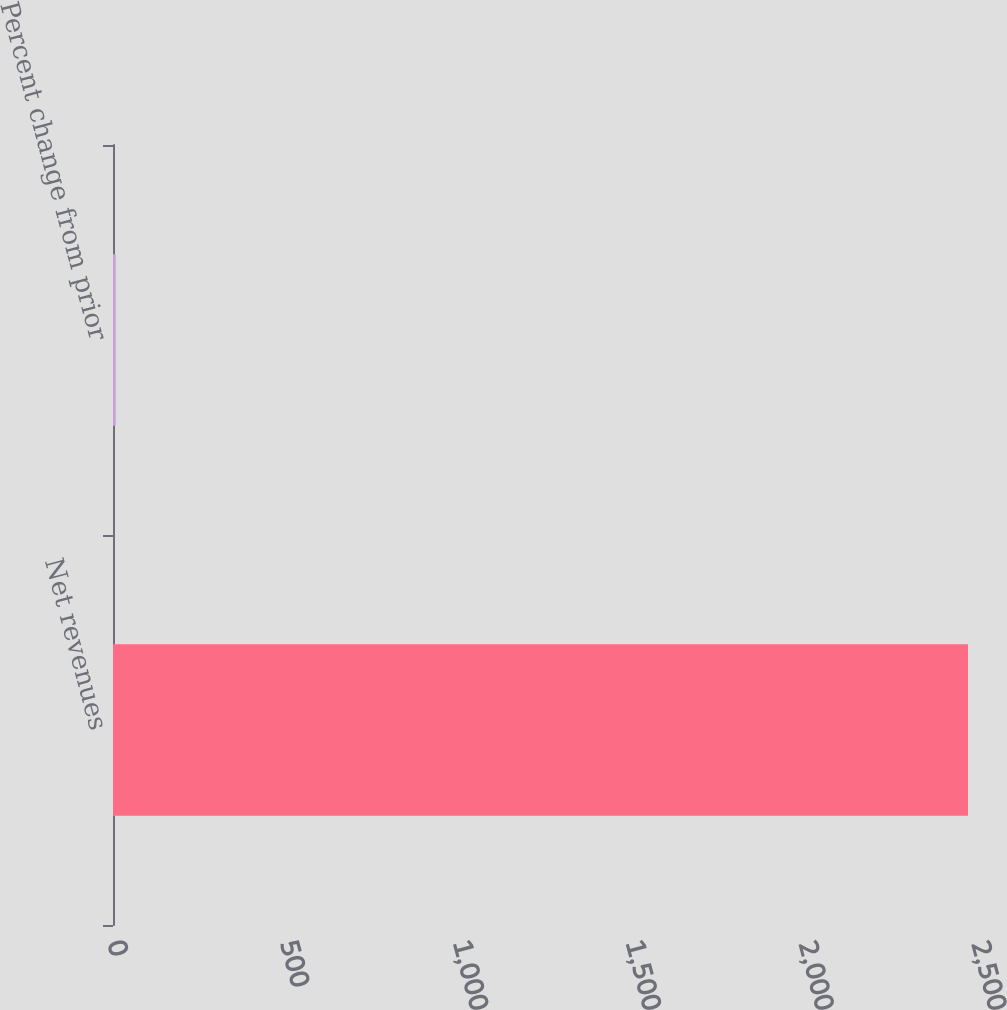Convert chart to OTSL. <chart><loc_0><loc_0><loc_500><loc_500><bar_chart><fcel>Net revenues<fcel>Percent change from prior<nl><fcel>2474<fcel>8<nl></chart> 